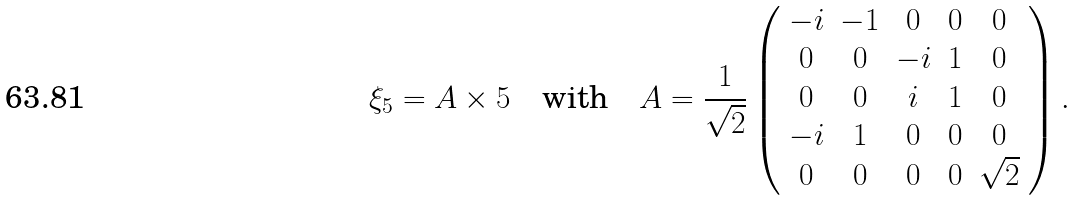Convert formula to latex. <formula><loc_0><loc_0><loc_500><loc_500>\xi _ { 5 } = A \times 5 \quad \text {with} \quad A = \frac { 1 } { \sqrt { 2 } } \left ( \begin{array} { c c c c c } - i & - 1 & 0 & 0 & 0 \\ 0 & 0 & - i & 1 & 0 \\ 0 & 0 & i & 1 & 0 \\ - i & 1 & 0 & 0 & 0 \\ 0 & 0 & 0 & 0 & \sqrt { 2 } \end{array} \right ) .</formula> 